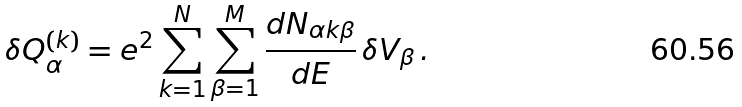Convert formula to latex. <formula><loc_0><loc_0><loc_500><loc_500>\delta Q ^ { ( k ) } _ { \alpha } = e ^ { 2 } \sum _ { k = 1 } ^ { N } \sum _ { \beta = 1 } ^ { M } \frac { d N _ { \alpha k \beta } } { d E } \, \delta V _ { \beta } \, .</formula> 